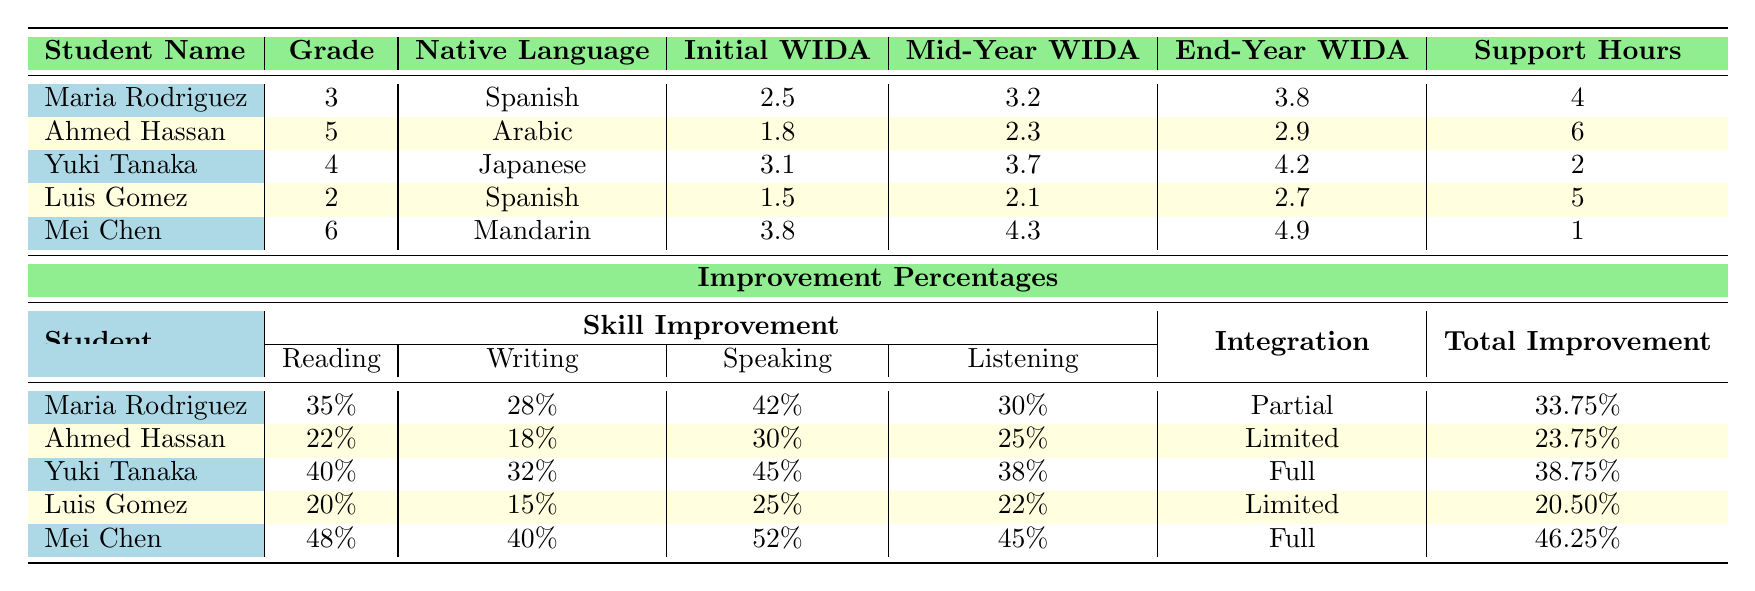What is the initial WIDA score of Maria Rodriguez? The initial WIDA score of Maria Rodriguez is listed in the table under the "Initial WIDA Score" column for her row. That value is 2.5.
Answer: 2.5 Which student had the highest end-year WIDA score? By checking the "End-Year WIDA Score" column, we find that Mei Chen has the highest score of 4.9 among all students.
Answer: Mei Chen What is the average reading improvement percentage of all students? To calculate the average reading improvement, we add the reading improvements: 35% + 22% + 40% + 20% + 48% = 165%. There are 5 students, so the average is 165% / 5 = 33%.
Answer: 33% How many students achieved a speaking improvement of over 40%? Looking at the 'Speaking Improvement' column, Maria Rodriguez (42%), Yuki Tanaka (45%), and Mei Chen (52%) all have improvements over 40%. Thus, there are 3 students who meet this criterion.
Answer: 3 What is the difference in WIDA scores between the initial and end-year for Luis Gomez? For Luis Gomez, the initial WIDA score is 1.5 and the end-year WIDA score is 2.7. The difference is calculated by subtracting: 2.7 - 1.5 = 1.2.
Answer: 1.2 Is Yuki Tanaka's native language Japanese? The table specifies Yuki Tanaka's native language in the "Native Language" column as Japanese, confirming the statement is true.
Answer: Yes What percentage improvement did Mei Chen experience in writing? To find Mei Chen's improvement in writing, we observe her writing improvement listed in the table, which is 40%.
Answer: 40% Who received the most additional support hours? The 'Additional Support Hours' column shows that Ahmed Hassan received 6 hours, which is more than any other student, so he has the highest.
Answer: Ahmed Hassan If you combine the speaking improvements of all students, what is the total percentage improvement? Summing the speaking improvements: 42% (Maria) + 30% (Ahmed) + 45% (Yuki) + 25% (Luis) + 52% (Mei) gives us a total of 194%.
Answer: 194% What is the mainstream class integration level for Maria Rodriguez? The integration level for Maria Rodriguez is listed in the "Mainstream Class Integration" column as Partial.
Answer: Partial 